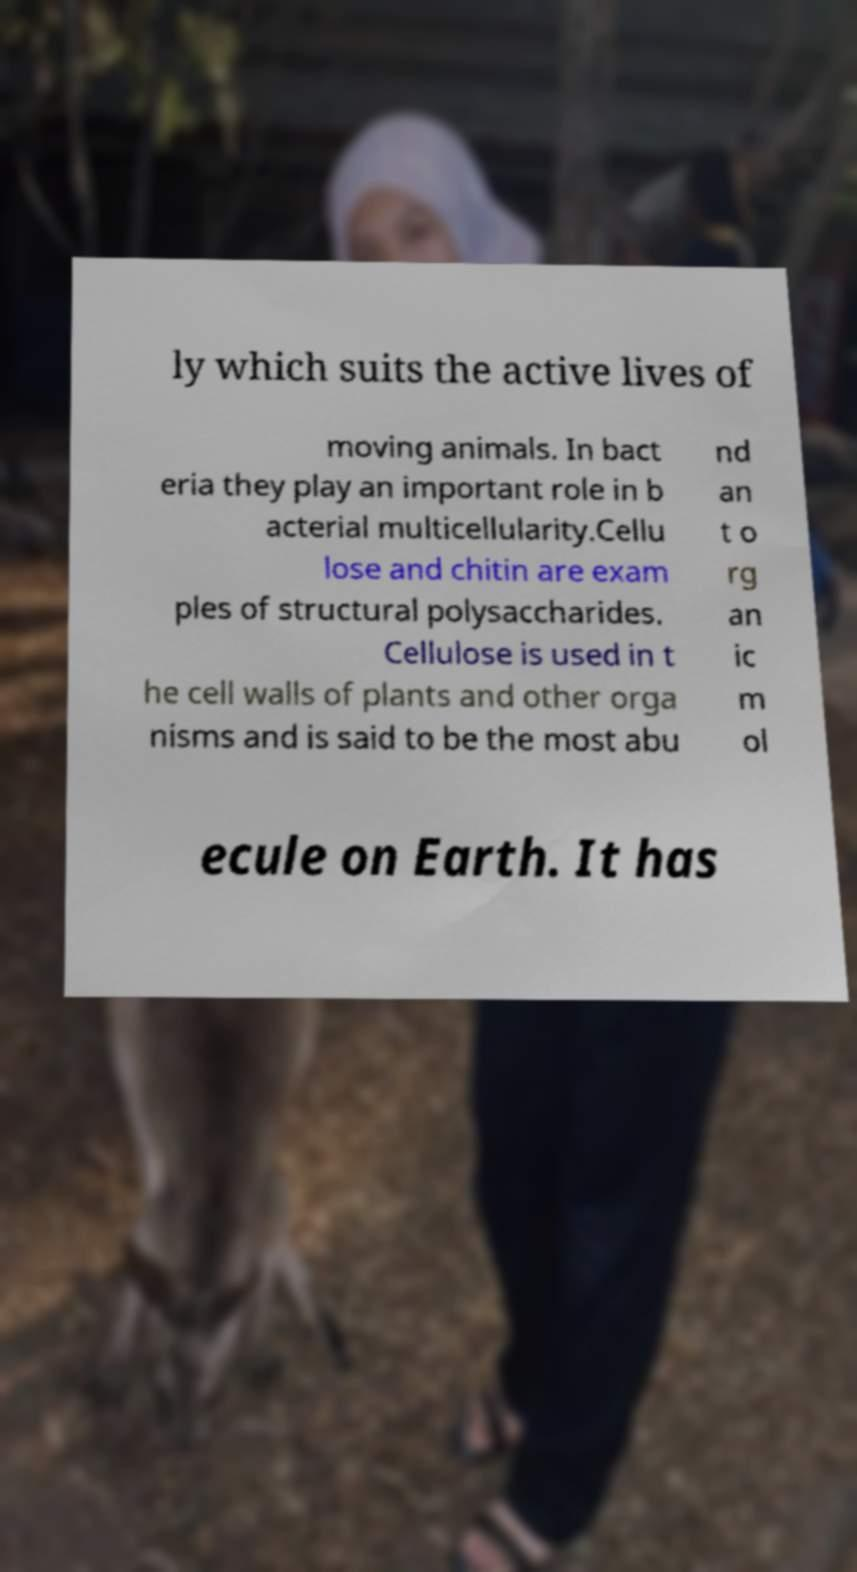Could you assist in decoding the text presented in this image and type it out clearly? ly which suits the active lives of moving animals. In bact eria they play an important role in b acterial multicellularity.Cellu lose and chitin are exam ples of structural polysaccharides. Cellulose is used in t he cell walls of plants and other orga nisms and is said to be the most abu nd an t o rg an ic m ol ecule on Earth. It has 